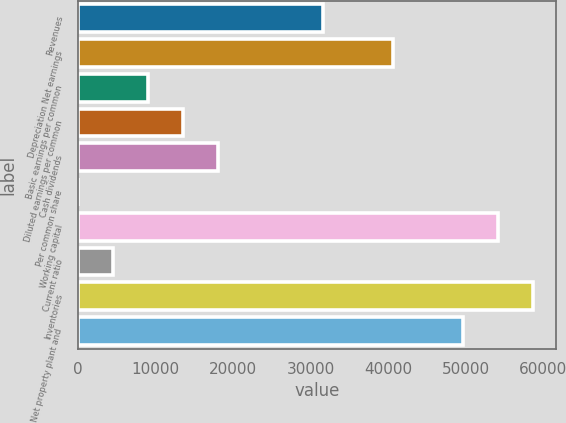Convert chart to OTSL. <chart><loc_0><loc_0><loc_500><loc_500><bar_chart><fcel>Revenues<fcel>Depreciation Net earnings<fcel>Basic earnings per common<fcel>Diluted earnings per common<fcel>Cash dividends<fcel>Per common share<fcel>Working capital<fcel>Current ratio<fcel>Inventories<fcel>Net property plant and<nl><fcel>31595.4<fcel>40622.5<fcel>9027.76<fcel>13541.3<fcel>18054.8<fcel>0.7<fcel>54163.1<fcel>4514.23<fcel>58676.6<fcel>49649.5<nl></chart> 